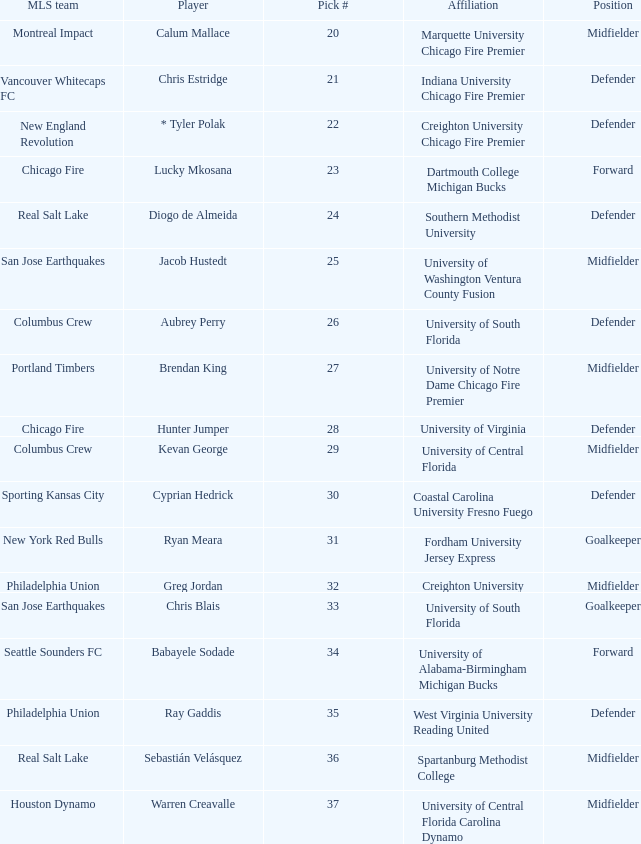What pick number did Real Salt Lake get? 24.0. 